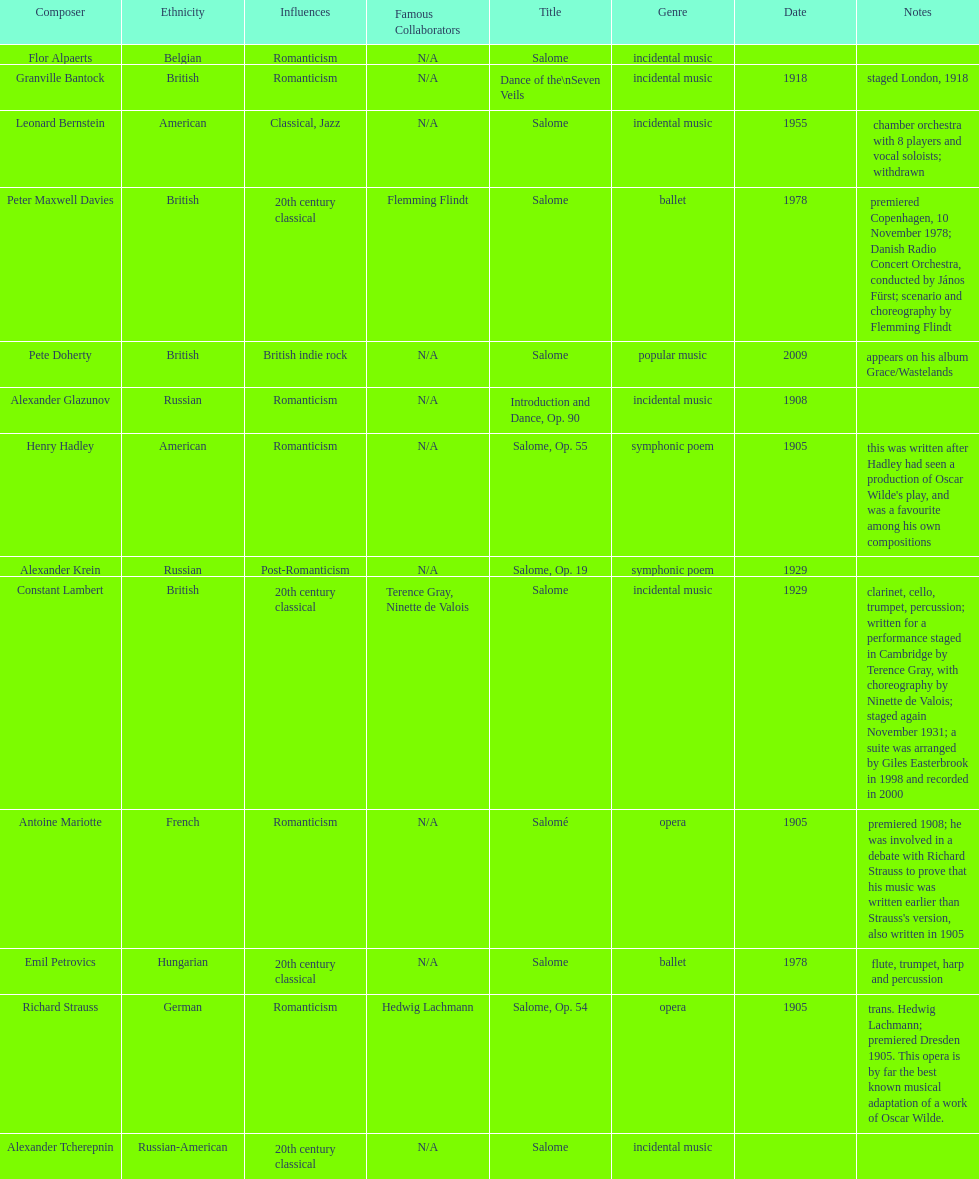Which composer published first granville bantock or emil petrovics? Granville Bantock. 